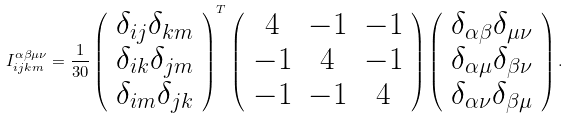Convert formula to latex. <formula><loc_0><loc_0><loc_500><loc_500>I _ { i j k m } ^ { \alpha \beta \mu \nu } = \frac { 1 } { 3 0 } \left ( \begin{array} { c c c } \delta _ { i j } \delta _ { k m } \\ \delta _ { i k } \delta _ { j m } \\ \delta _ { i m } \delta _ { j k } \end{array} \right ) ^ { T } \left ( \begin{array} { c c c } 4 & - 1 & - 1 \\ - 1 & 4 & - 1 \\ - 1 & - 1 & 4 \end{array} \right ) \left ( \begin{array} { c c c } \delta _ { \alpha \beta } \delta _ { \mu \nu } \\ \delta _ { \alpha \mu } \delta _ { \beta \nu } \\ \delta _ { \alpha \nu } \delta _ { \beta \mu } \end{array} \right ) .</formula> 